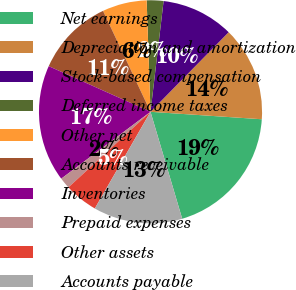<chart> <loc_0><loc_0><loc_500><loc_500><pie_chart><fcel>Net earnings<fcel>Depreciation and amortization<fcel>Stock-based compensation<fcel>Deferred income taxes<fcel>Other net<fcel>Accounts receivable<fcel>Inventories<fcel>Prepaid expenses<fcel>Other assets<fcel>Accounts payable<nl><fcel>19.35%<fcel>13.71%<fcel>10.48%<fcel>2.42%<fcel>6.45%<fcel>11.29%<fcel>16.94%<fcel>1.61%<fcel>4.84%<fcel>12.9%<nl></chart> 